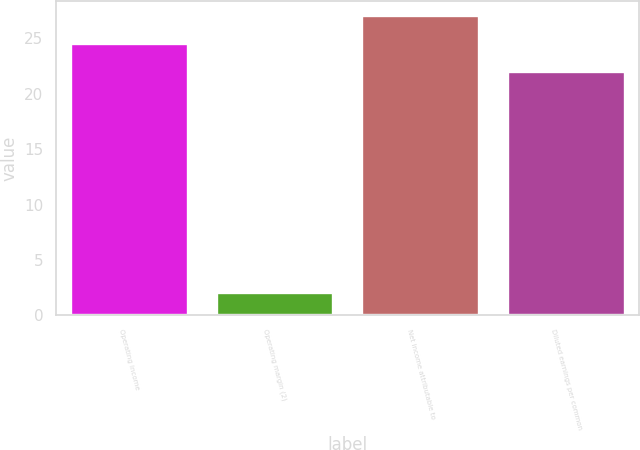Convert chart to OTSL. <chart><loc_0><loc_0><loc_500><loc_500><bar_chart><fcel>Operating income<fcel>Operating margin (2)<fcel>Net income attributable to<fcel>Diluted earnings per common<nl><fcel>24.5<fcel>2<fcel>27<fcel>22<nl></chart> 